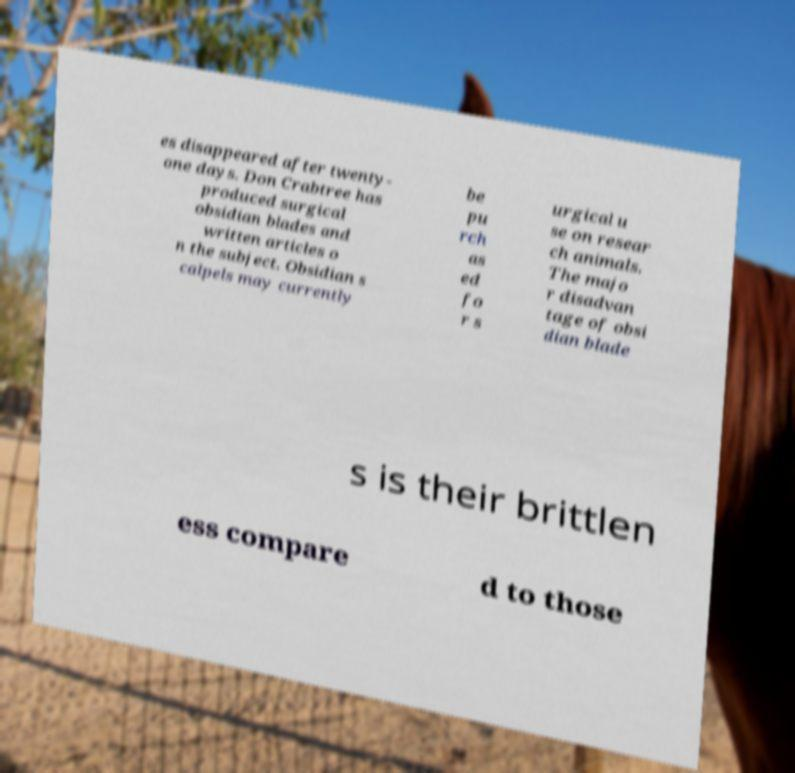Please identify and transcribe the text found in this image. es disappeared after twenty- one days. Don Crabtree has produced surgical obsidian blades and written articles o n the subject. Obsidian s calpels may currently be pu rch as ed fo r s urgical u se on resear ch animals. The majo r disadvan tage of obsi dian blade s is their brittlen ess compare d to those 